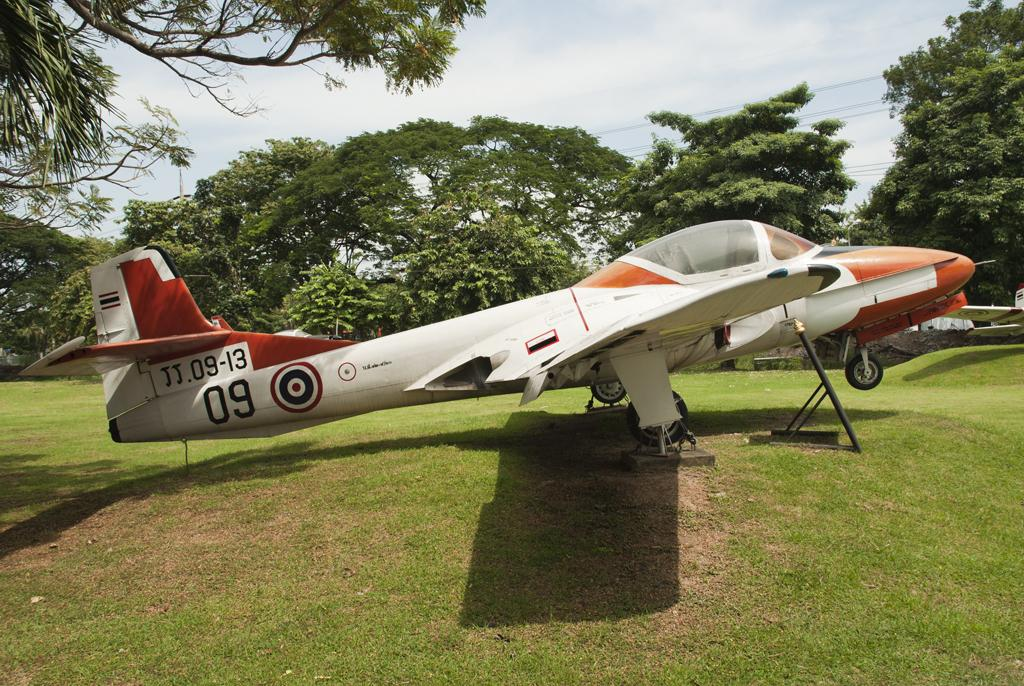What is the main subject of the image? The main subject of the image is an aircraft. What can be seen on the path in the image? There is an object on the path in the image. What type of vegetation is visible in the image? Trees are visible in the image. What else is present in the image besides the aircraft and trees? Cables and a pole are present in the image. What is visible in the background of the image? The sky is visible in the image. Can you tell me how many records are being played in the image? There are no records present in the image; it features an aircraft, an object on the path, trees, cables, a pole, and the sky. Is there a unit of measurement visible in the image? There is no unit of measurement present in the image. 